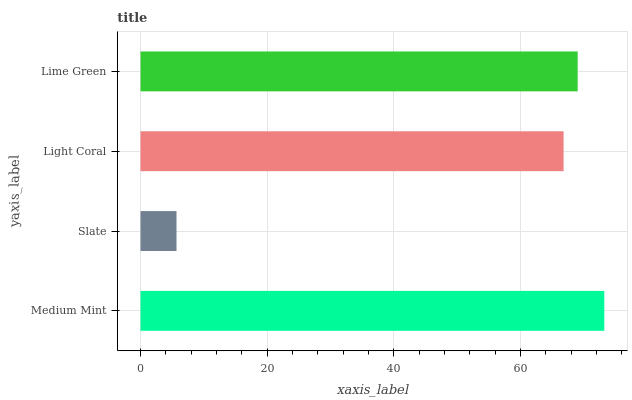Is Slate the minimum?
Answer yes or no. Yes. Is Medium Mint the maximum?
Answer yes or no. Yes. Is Light Coral the minimum?
Answer yes or no. No. Is Light Coral the maximum?
Answer yes or no. No. Is Light Coral greater than Slate?
Answer yes or no. Yes. Is Slate less than Light Coral?
Answer yes or no. Yes. Is Slate greater than Light Coral?
Answer yes or no. No. Is Light Coral less than Slate?
Answer yes or no. No. Is Lime Green the high median?
Answer yes or no. Yes. Is Light Coral the low median?
Answer yes or no. Yes. Is Light Coral the high median?
Answer yes or no. No. Is Lime Green the low median?
Answer yes or no. No. 